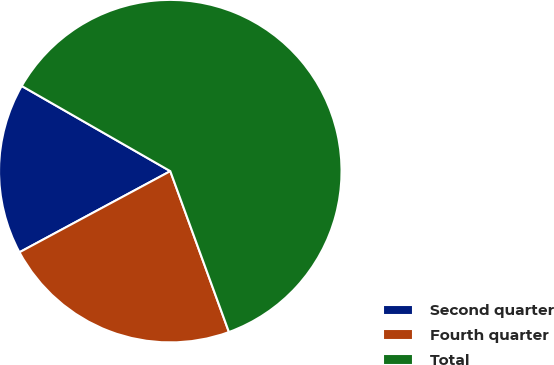Convert chart to OTSL. <chart><loc_0><loc_0><loc_500><loc_500><pie_chart><fcel>Second quarter<fcel>Fourth quarter<fcel>Total<nl><fcel>16.14%<fcel>22.71%<fcel>61.16%<nl></chart> 